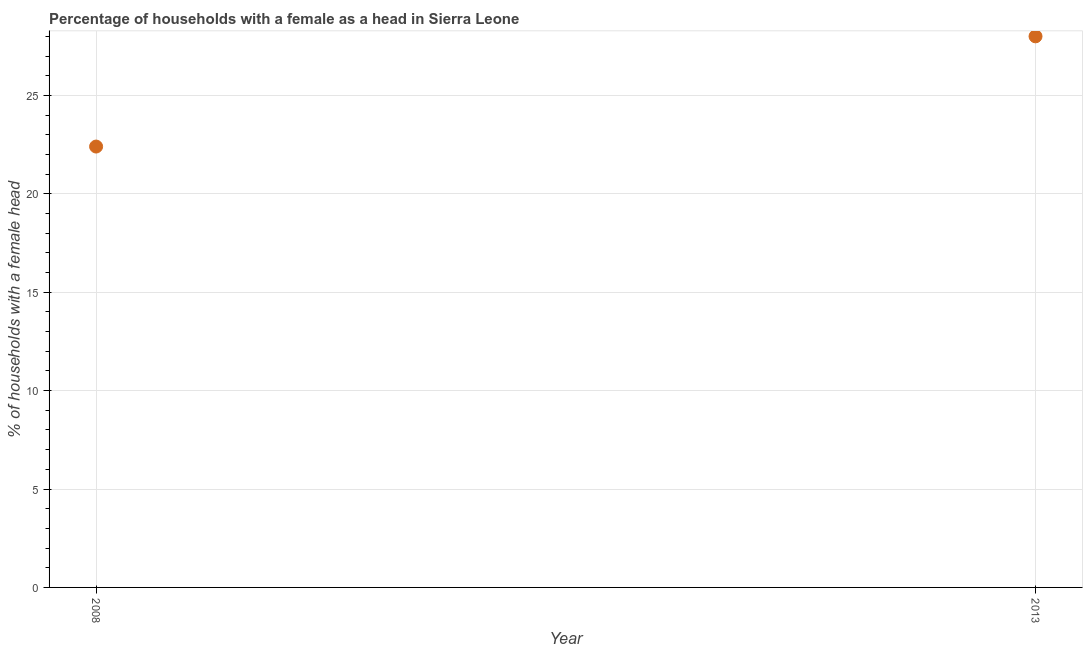Across all years, what is the maximum number of female supervised households?
Give a very brief answer. 28. Across all years, what is the minimum number of female supervised households?
Make the answer very short. 22.4. In which year was the number of female supervised households maximum?
Offer a terse response. 2013. In which year was the number of female supervised households minimum?
Keep it short and to the point. 2008. What is the sum of the number of female supervised households?
Offer a very short reply. 50.4. What is the difference between the number of female supervised households in 2008 and 2013?
Make the answer very short. -5.6. What is the average number of female supervised households per year?
Your answer should be compact. 25.2. What is the median number of female supervised households?
Offer a terse response. 25.2. In how many years, is the number of female supervised households greater than 6 %?
Your answer should be compact. 2. What is the ratio of the number of female supervised households in 2008 to that in 2013?
Your answer should be very brief. 0.8. Is the number of female supervised households in 2008 less than that in 2013?
Offer a very short reply. Yes. In how many years, is the number of female supervised households greater than the average number of female supervised households taken over all years?
Give a very brief answer. 1. How many dotlines are there?
Provide a succinct answer. 1. How many years are there in the graph?
Your answer should be compact. 2. What is the difference between two consecutive major ticks on the Y-axis?
Ensure brevity in your answer.  5. Does the graph contain any zero values?
Offer a very short reply. No. What is the title of the graph?
Offer a very short reply. Percentage of households with a female as a head in Sierra Leone. What is the label or title of the Y-axis?
Your answer should be very brief. % of households with a female head. What is the % of households with a female head in 2008?
Your answer should be compact. 22.4. What is the % of households with a female head in 2013?
Ensure brevity in your answer.  28. What is the difference between the % of households with a female head in 2008 and 2013?
Offer a very short reply. -5.6. What is the ratio of the % of households with a female head in 2008 to that in 2013?
Your answer should be compact. 0.8. 